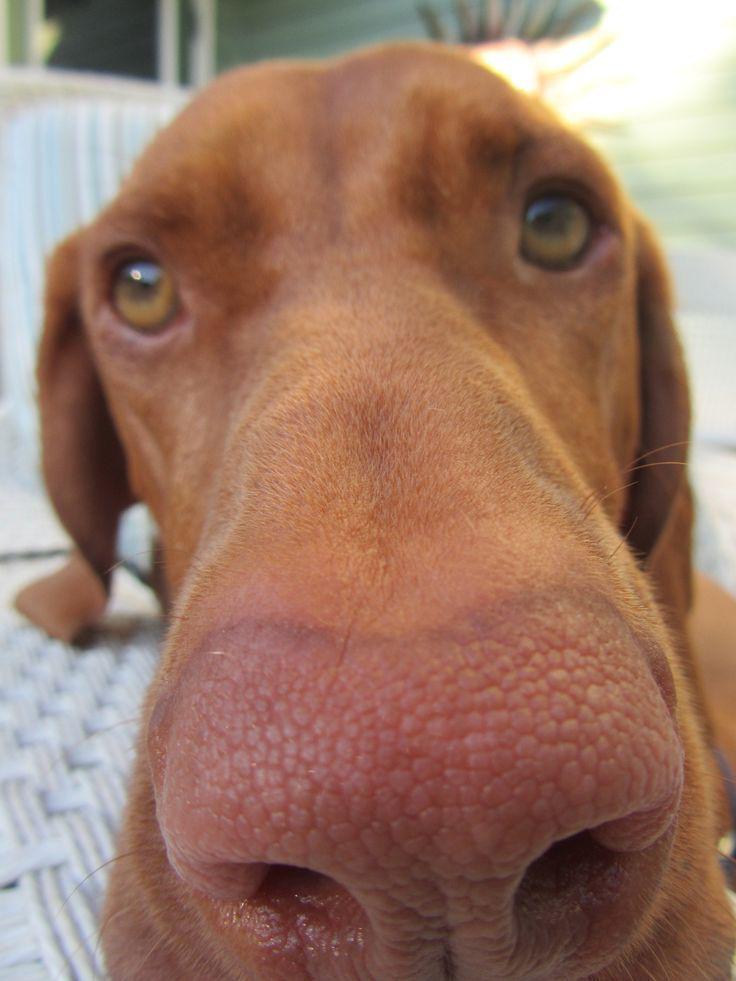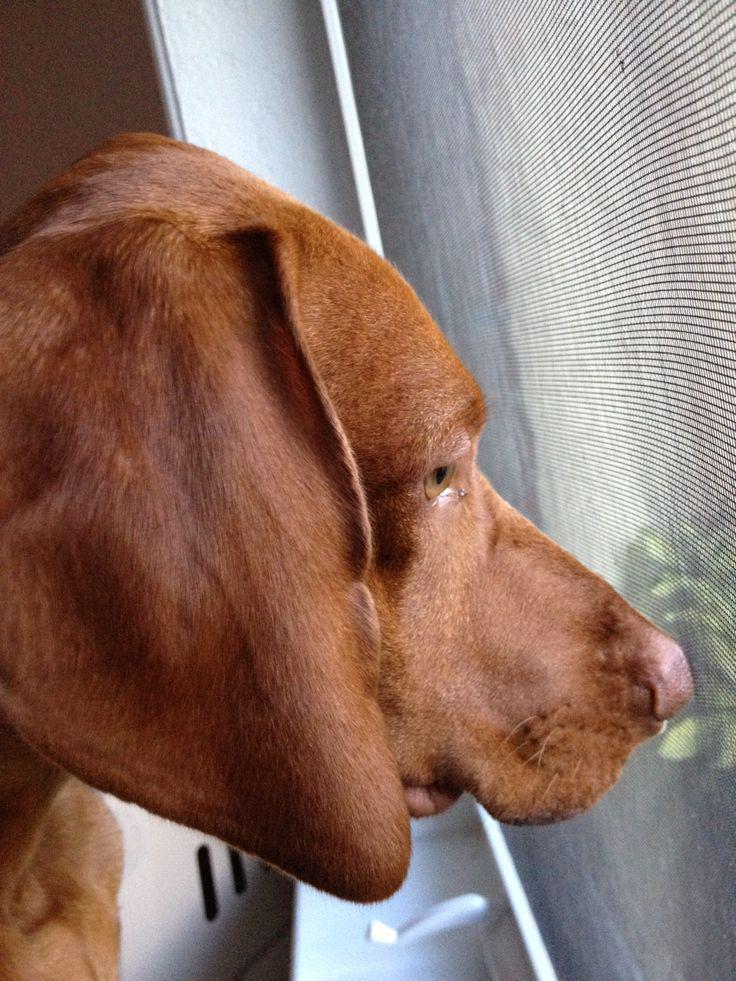The first image is the image on the left, the second image is the image on the right. Considering the images on both sides, is "The left image includes at least one extended paw in the foreground, and a collar worn by a reclining dog." valid? Answer yes or no. No. The first image is the image on the left, the second image is the image on the right. Assess this claim about the two images: "Two dogs are looking into the camera.". Correct or not? Answer yes or no. No. 